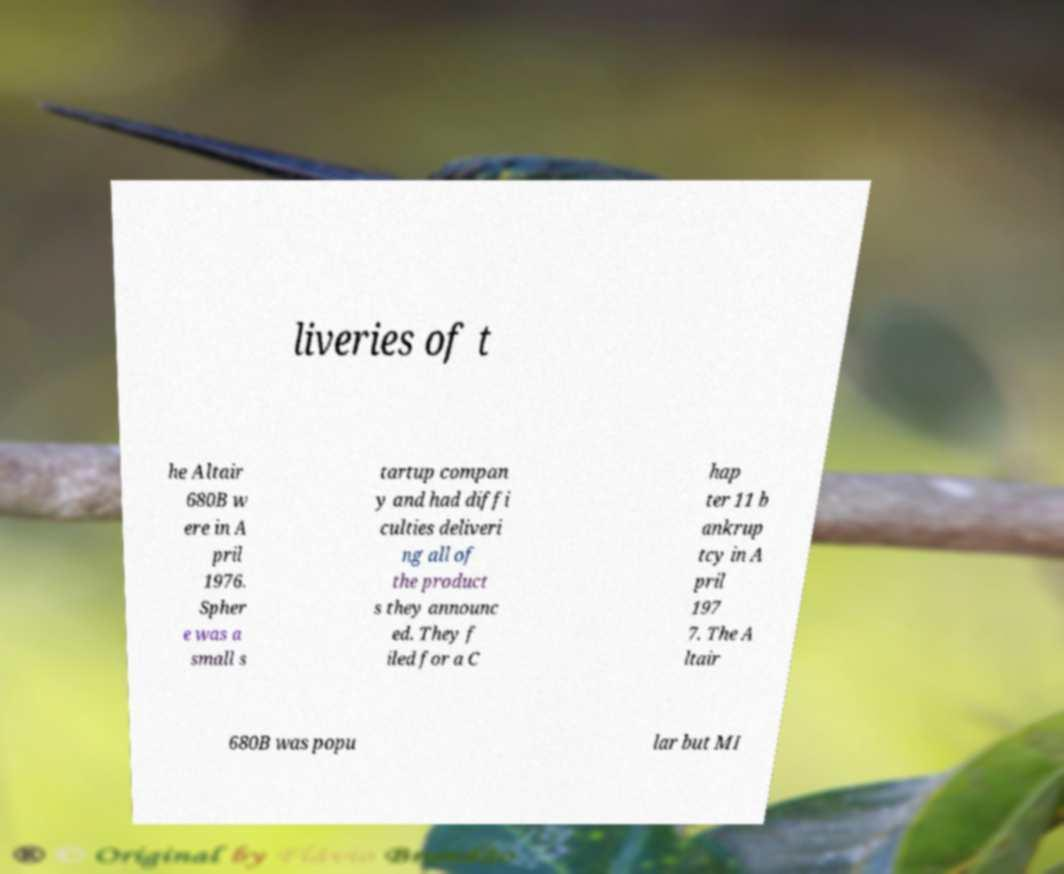There's text embedded in this image that I need extracted. Can you transcribe it verbatim? liveries of t he Altair 680B w ere in A pril 1976. Spher e was a small s tartup compan y and had diffi culties deliveri ng all of the product s they announc ed. They f iled for a C hap ter 11 b ankrup tcy in A pril 197 7. The A ltair 680B was popu lar but MI 